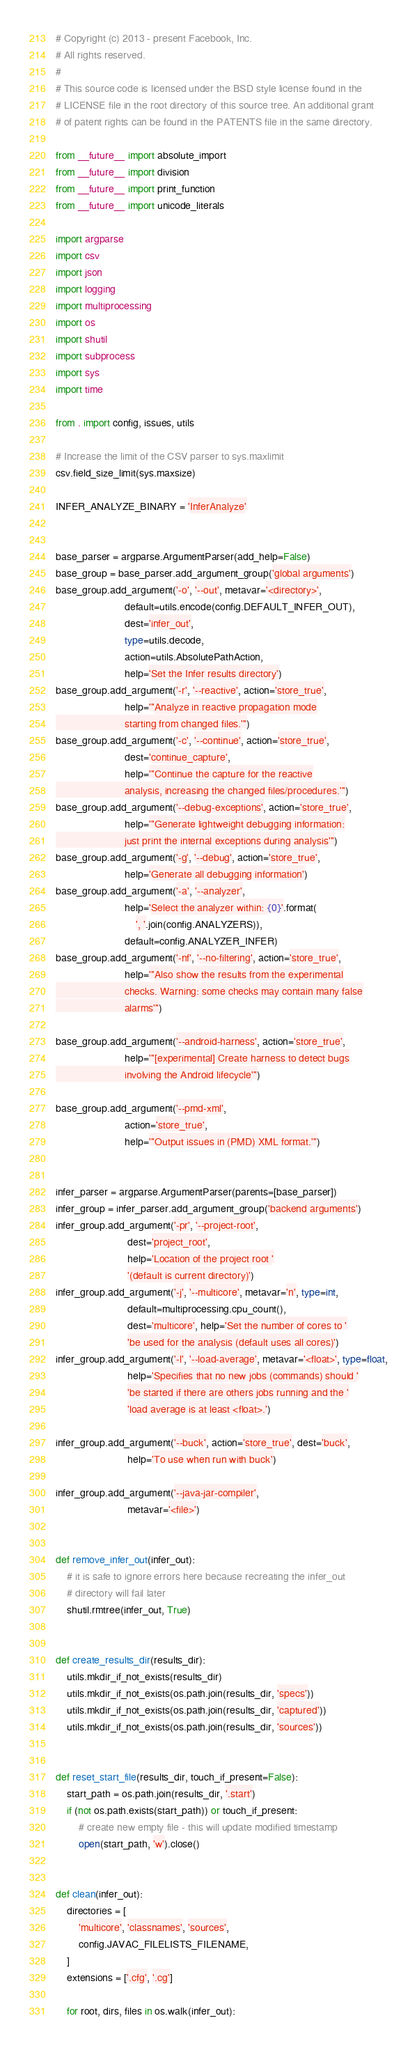Convert code to text. <code><loc_0><loc_0><loc_500><loc_500><_Python_># Copyright (c) 2013 - present Facebook, Inc.
# All rights reserved.
#
# This source code is licensed under the BSD style license found in the
# LICENSE file in the root directory of this source tree. An additional grant
# of patent rights can be found in the PATENTS file in the same directory.

from __future__ import absolute_import
from __future__ import division
from __future__ import print_function
from __future__ import unicode_literals

import argparse
import csv
import json
import logging
import multiprocessing
import os
import shutil
import subprocess
import sys
import time

from . import config, issues, utils

# Increase the limit of the CSV parser to sys.maxlimit
csv.field_size_limit(sys.maxsize)

INFER_ANALYZE_BINARY = 'InferAnalyze'


base_parser = argparse.ArgumentParser(add_help=False)
base_group = base_parser.add_argument_group('global arguments')
base_group.add_argument('-o', '--out', metavar='<directory>',
                        default=utils.encode(config.DEFAULT_INFER_OUT),
                        dest='infer_out',
                        type=utils.decode,
                        action=utils.AbsolutePathAction,
                        help='Set the Infer results directory')
base_group.add_argument('-r', '--reactive', action='store_true',
                        help='''Analyze in reactive propagation mode
                        starting from changed files.''')
base_group.add_argument('-c', '--continue', action='store_true',
                        dest='continue_capture',
                        help='''Continue the capture for the reactive
                        analysis, increasing the changed files/procedures.''')
base_group.add_argument('--debug-exceptions', action='store_true',
                        help='''Generate lightweight debugging information:
                        just print the internal exceptions during analysis''')
base_group.add_argument('-g', '--debug', action='store_true',
                        help='Generate all debugging information')
base_group.add_argument('-a', '--analyzer',
                        help='Select the analyzer within: {0}'.format(
                            ', '.join(config.ANALYZERS)),
                        default=config.ANALYZER_INFER)
base_group.add_argument('-nf', '--no-filtering', action='store_true',
                        help='''Also show the results from the experimental
                        checks. Warning: some checks may contain many false
                        alarms''')

base_group.add_argument('--android-harness', action='store_true',
                        help='''[experimental] Create harness to detect bugs
                        involving the Android lifecycle''')

base_group.add_argument('--pmd-xml',
                        action='store_true',
                        help='''Output issues in (PMD) XML format.''')


infer_parser = argparse.ArgumentParser(parents=[base_parser])
infer_group = infer_parser.add_argument_group('backend arguments')
infer_group.add_argument('-pr', '--project-root',
                         dest='project_root',
                         help='Location of the project root '
                         '(default is current directory)')
infer_group.add_argument('-j', '--multicore', metavar='n', type=int,
                         default=multiprocessing.cpu_count(),
                         dest='multicore', help='Set the number of cores to '
                         'be used for the analysis (default uses all cores)')
infer_group.add_argument('-l', '--load-average', metavar='<float>', type=float,
                         help='Specifies that no new jobs (commands) should '
                         'be started if there are others jobs running and the '
                         'load average is at least <float>.')

infer_group.add_argument('--buck', action='store_true', dest='buck',
                         help='To use when run with buck')

infer_group.add_argument('--java-jar-compiler',
                         metavar='<file>')


def remove_infer_out(infer_out):
    # it is safe to ignore errors here because recreating the infer_out
    # directory will fail later
    shutil.rmtree(infer_out, True)


def create_results_dir(results_dir):
    utils.mkdir_if_not_exists(results_dir)
    utils.mkdir_if_not_exists(os.path.join(results_dir, 'specs'))
    utils.mkdir_if_not_exists(os.path.join(results_dir, 'captured'))
    utils.mkdir_if_not_exists(os.path.join(results_dir, 'sources'))


def reset_start_file(results_dir, touch_if_present=False):
    start_path = os.path.join(results_dir, '.start')
    if (not os.path.exists(start_path)) or touch_if_present:
        # create new empty file - this will update modified timestamp
        open(start_path, 'w').close()


def clean(infer_out):
    directories = [
        'multicore', 'classnames', 'sources',
        config.JAVAC_FILELISTS_FILENAME,
    ]
    extensions = ['.cfg', '.cg']

    for root, dirs, files in os.walk(infer_out):</code> 